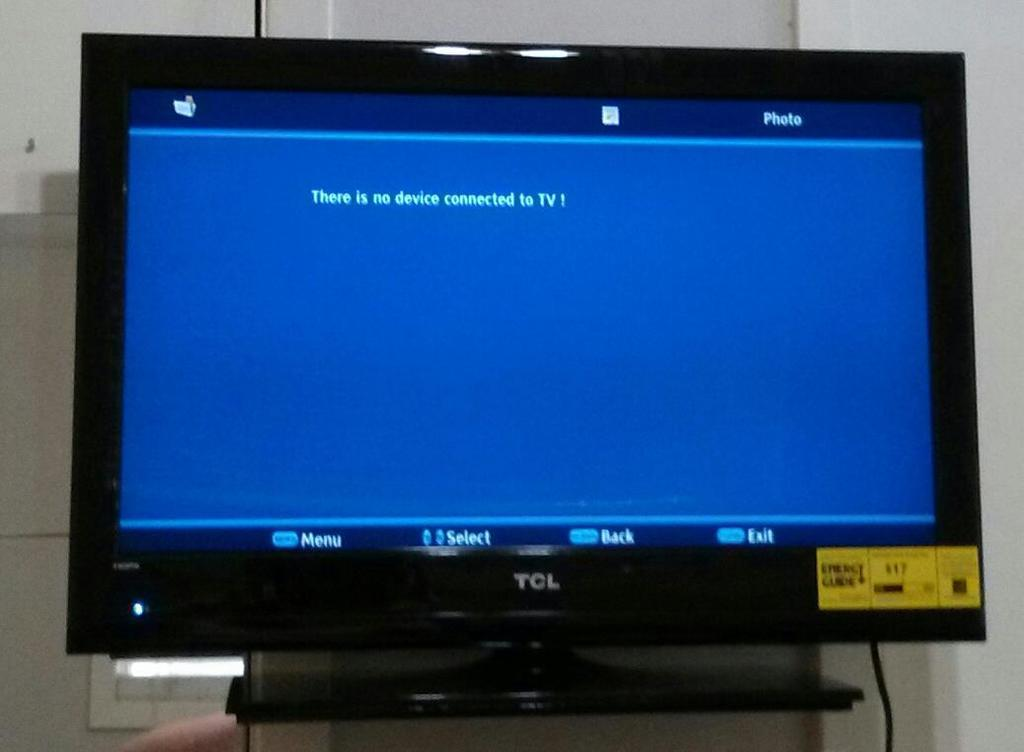<image>
Provide a brief description of the given image. A Tv screen tells us there is no device connected to it. 